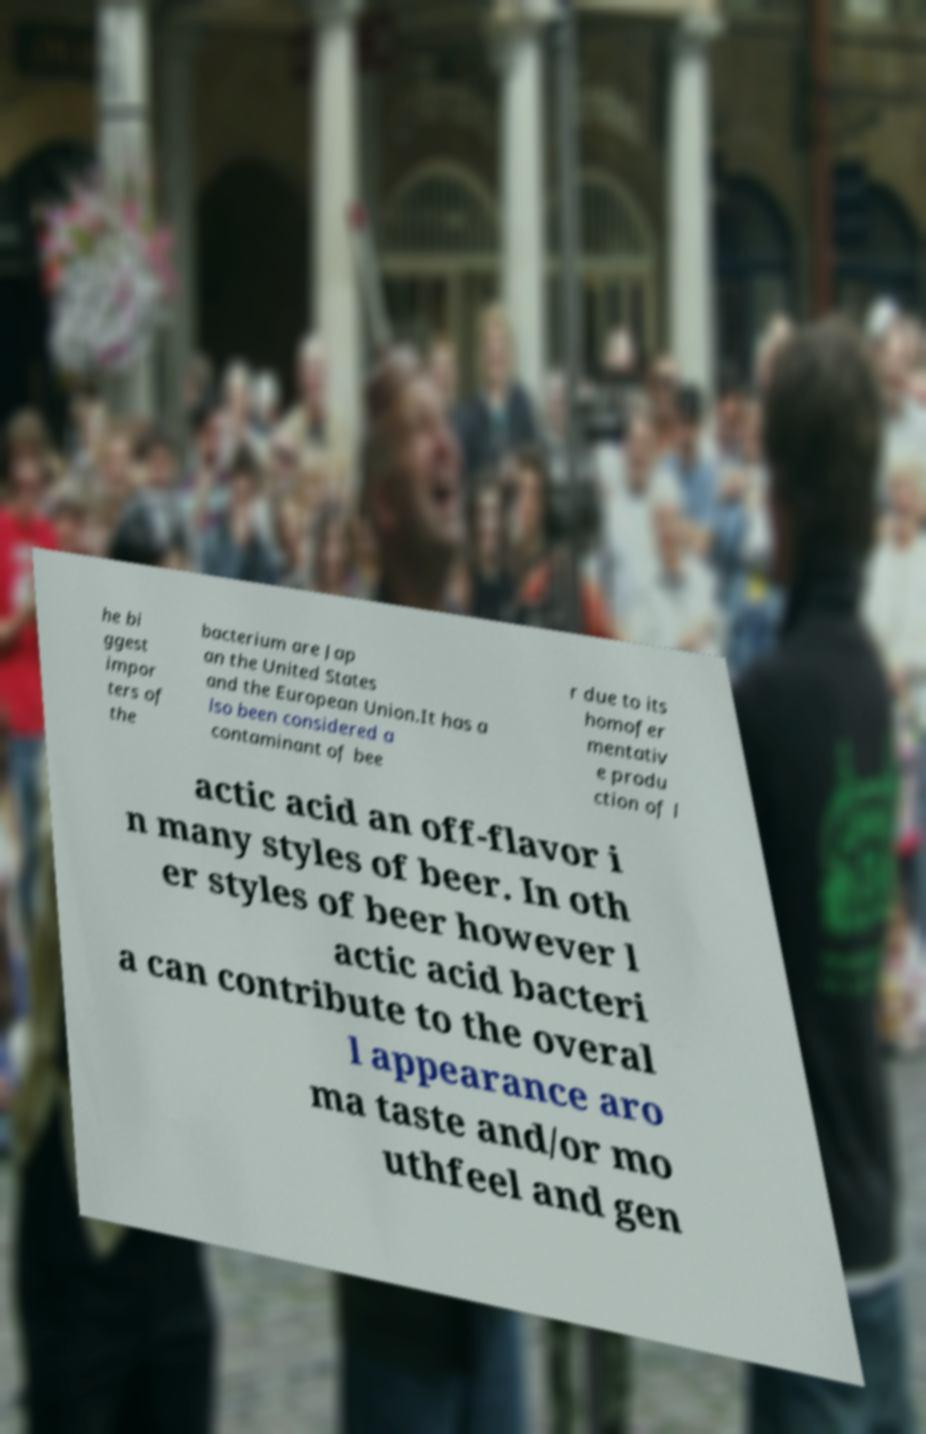Can you read and provide the text displayed in the image?This photo seems to have some interesting text. Can you extract and type it out for me? he bi ggest impor ters of the bacterium are Jap an the United States and the European Union.It has a lso been considered a contaminant of bee r due to its homofer mentativ e produ ction of l actic acid an off-flavor i n many styles of beer. In oth er styles of beer however l actic acid bacteri a can contribute to the overal l appearance aro ma taste and/or mo uthfeel and gen 